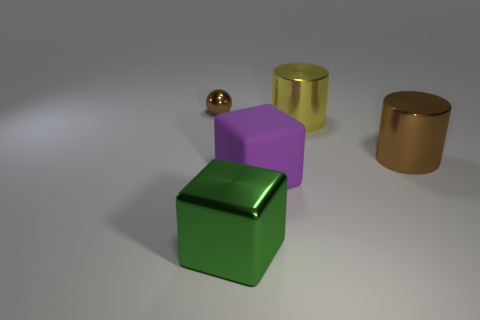Subtract all cyan cylinders. Subtract all blue cubes. How many cylinders are left? 2 Add 4 big rubber blocks. How many objects exist? 9 Subtract all spheres. How many objects are left? 4 Add 2 large cubes. How many large cubes are left? 4 Add 3 metal blocks. How many metal blocks exist? 4 Subtract 0 cyan cylinders. How many objects are left? 5 Subtract all spheres. Subtract all big brown metal objects. How many objects are left? 3 